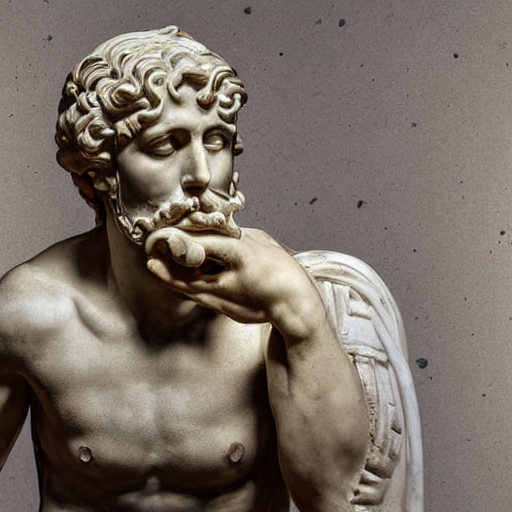How is the focus in the image?
A. Blurry
B. Unfocused
C. Precise
Answer with the option's letter from the given choices directly.
 C. 